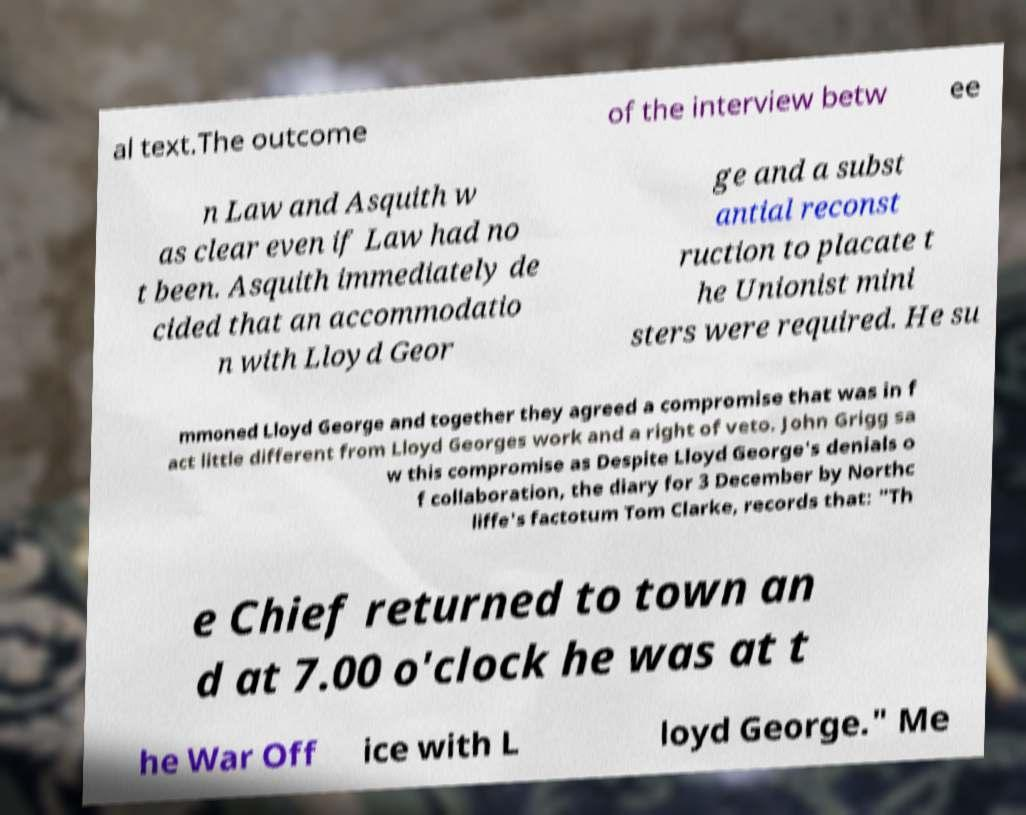Could you assist in decoding the text presented in this image and type it out clearly? al text.The outcome of the interview betw ee n Law and Asquith w as clear even if Law had no t been. Asquith immediately de cided that an accommodatio n with Lloyd Geor ge and a subst antial reconst ruction to placate t he Unionist mini sters were required. He su mmoned Lloyd George and together they agreed a compromise that was in f act little different from Lloyd Georges work and a right of veto. John Grigg sa w this compromise as Despite Lloyd George's denials o f collaboration, the diary for 3 December by Northc liffe's factotum Tom Clarke, records that: "Th e Chief returned to town an d at 7.00 o'clock he was at t he War Off ice with L loyd George." Me 